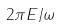Convert formula to latex. <formula><loc_0><loc_0><loc_500><loc_500>2 \pi E / \omega</formula> 